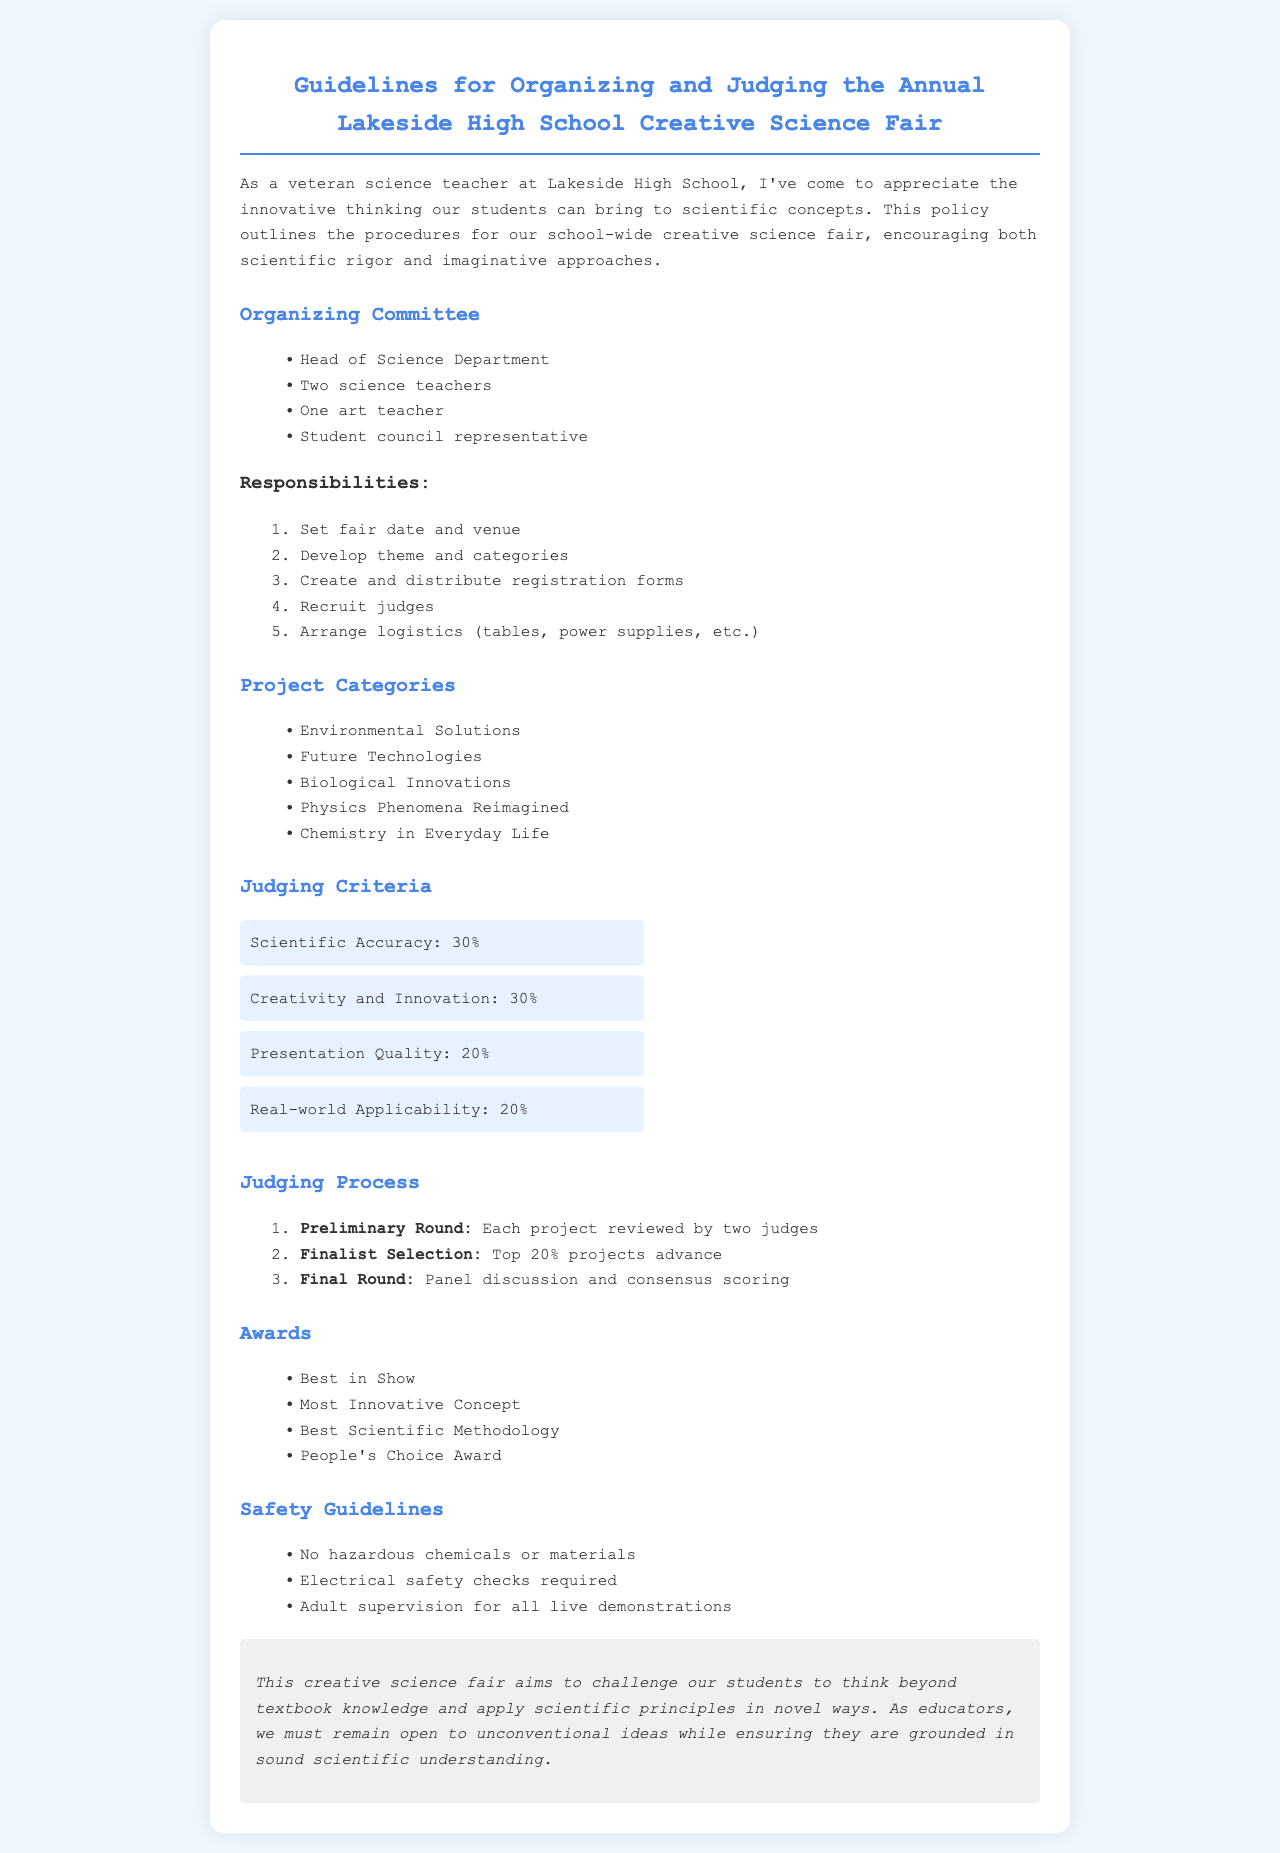What is the title of the document? The title is prominently displayed at the top of the document.
Answer: Guidelines for Organizing and Judging the Annual Lakeside High School Creative Science Fair Who is the head of the organizing committee? The head of the organizing committee is mentioned in the list of committee members.
Answer: Head of Science Department How many project categories are listed? The project categories are enumerated in a bulleted list.
Answer: Five What percentage of points is allocated to Scientific Accuracy? The judging criteria section specifies point allocations for each criterion.
Answer: 30% What is one of the awards that can be won? The awards section lists several possible awards for participants.
Answer: Best in Show What is the first step in the judging process? The judging process outlines steps in a numbered list.
Answer: Preliminary Round What type of safety guideline is mentioned? Safety guidelines are listed in a bulleted format that highlights important rules.
Answer: No hazardous chemicals or materials Which category focuses on innovation in technology? The project categories specifically relate to different themes in science.
Answer: Future Technologies How many judges review each project in the preliminary round? The details of the judging process indicate the number of judges involved.
Answer: Two 